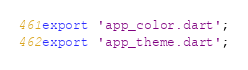Convert code to text. <code><loc_0><loc_0><loc_500><loc_500><_Dart_>export 'app_color.dart';
export 'app_theme.dart';
</code> 